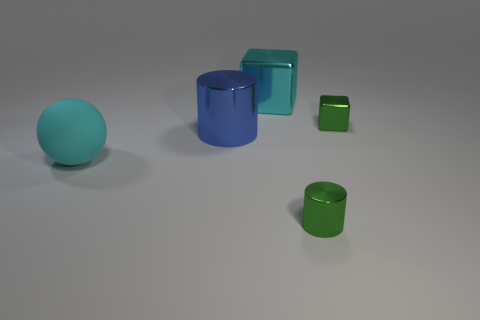How many objects are green shiny cylinders or large objects that are behind the cyan sphere?
Your answer should be compact. 3. There is a small shiny thing that is behind the big blue metal thing; does it have the same shape as the tiny shiny object in front of the large cyan sphere?
Offer a terse response. No. What number of objects are either tiny green blocks or cyan rubber objects?
Offer a very short reply. 2. Is there any other thing that has the same material as the large ball?
Provide a short and direct response. No. Are any tiny green shiny cylinders visible?
Offer a very short reply. Yes. Are the cylinder that is left of the tiny shiny cylinder and the green block made of the same material?
Make the answer very short. Yes. Are there any green metallic objects of the same shape as the blue metal thing?
Provide a short and direct response. Yes. Is the number of tiny green shiny cylinders that are left of the green cylinder the same as the number of big metallic cubes?
Provide a short and direct response. No. There is a small green object that is on the right side of the green metallic thing that is in front of the small green shiny cube; what is it made of?
Your response must be concise. Metal. The blue metal object is what shape?
Keep it short and to the point. Cylinder. 